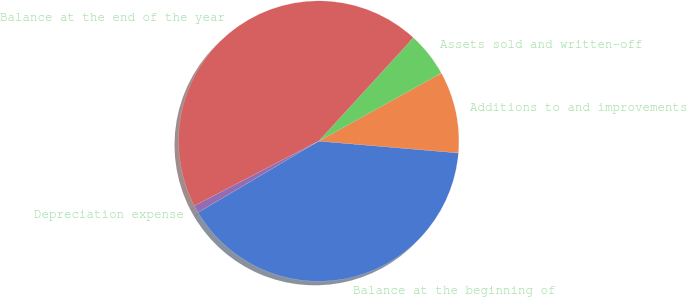<chart> <loc_0><loc_0><loc_500><loc_500><pie_chart><fcel>Balance at the beginning of<fcel>Additions to and improvements<fcel>Assets sold and written-off<fcel>Balance at the end of the year<fcel>Depreciation expense<nl><fcel>40.16%<fcel>9.41%<fcel>5.14%<fcel>44.44%<fcel>0.86%<nl></chart> 